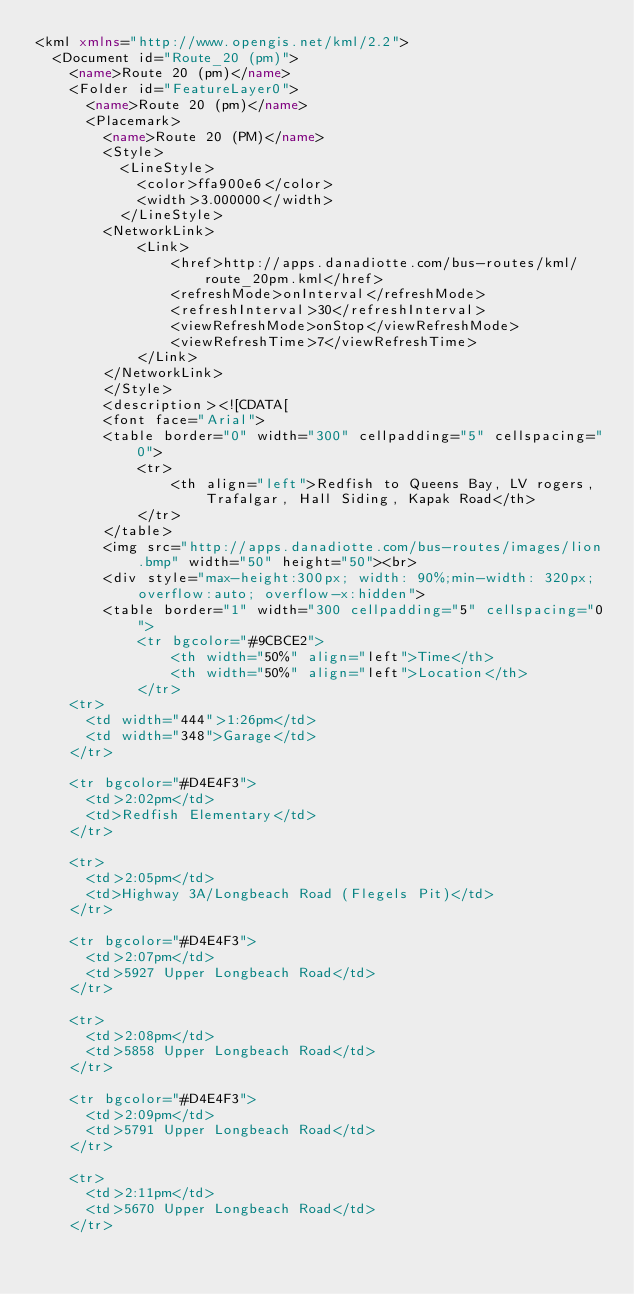Convert code to text. <code><loc_0><loc_0><loc_500><loc_500><_XML_><kml xmlns="http://www.opengis.net/kml/2.2">
  <Document id="Route_20 (pm)">
    <name>Route 20 (pm)</name>
    <Folder id="FeatureLayer0">
      <name>Route 20 (pm)</name>
      <Placemark>
        <name>Route 20 (PM)</name>
        <Style>
          <LineStyle>
            <color>ffa900e6</color>
            <width>3.000000</width>
          </LineStyle>
		<NetworkLink>
	        <Link>
				<href>http://apps.danadiotte.com/bus-routes/kml/route_20pm.kml</href>
	    		<refreshMode>onInterval</refreshMode>
	    		<refreshInterval>30</refreshInterval>
	    		<viewRefreshMode>onStop</viewRefreshMode>
	    		<viewRefreshTime>7</viewRefreshTime>
	    	</Link>
    	</NetworkLink>
        </Style>
        <description><![CDATA[
		<font face="Arial">
		<table border="0" width="300" cellpadding="5" cellspacing="0">
		    <tr>
				<th align="left">Redfish to Queens Bay, LV rogers, Trafalgar, Hall Siding, Kapak Road</th>
			</tr>
		</table>
		<img src="http://apps.danadiotte.com/bus-routes/images/lion.bmp" width="50" height="50"><br>
		<div style="max-height:300px; width: 90%;min-width: 320px;overflow:auto; overflow-x:hidden">
        <table border="1" width="300 cellpadding="5" cellspacing="0">
		    <tr bgcolor="#9CBCE2">
				<th width="50%" align="left">Time</th>
				<th width="50%" align="left">Location</th>
			</tr>
    <tr>
      <td width="444">1:26pm</td>
      <td width="348">Garage</td>
    </tr>

    <tr bgcolor="#D4E4F3">
      <td>2:02pm</td>
      <td>Redfish Elementary</td>
    </tr>

    <tr>
      <td>2:05pm</td>
      <td>Highway 3A/Longbeach Road (Flegels Pit)</td>
    </tr>

    <tr bgcolor="#D4E4F3">
      <td>2:07pm</td>
      <td>5927 Upper Longbeach Road</td>
    </tr>

    <tr>
      <td>2:08pm</td>
      <td>5858 Upper Longbeach Road</td>
    </tr>

    <tr bgcolor="#D4E4F3">
      <td>2:09pm</td>
      <td>5791 Upper Longbeach Road</td>
    </tr>

    <tr>
      <td>2:11pm</td>
      <td>5670 Upper Longbeach Road</td>
    </tr>
</code> 